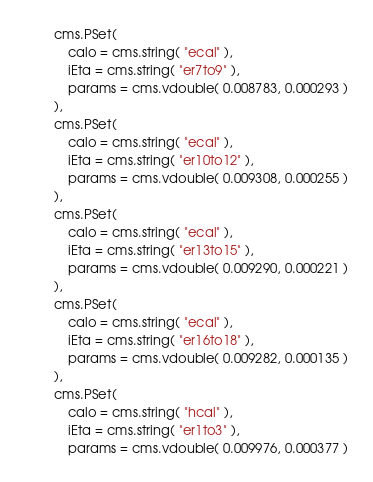Convert code to text. <code><loc_0><loc_0><loc_500><loc_500><_Python_>		cms.PSet(
			calo = cms.string( "ecal" ),
			iEta = cms.string( "er7to9" ),
			params = cms.vdouble( 0.008783, 0.000293 )
		),
		cms.PSet(
			calo = cms.string( "ecal" ),
			iEta = cms.string( "er10to12" ),
			params = cms.vdouble( 0.009308, 0.000255 )
		),
		cms.PSet(
			calo = cms.string( "ecal" ),
			iEta = cms.string( "er13to15" ),
			params = cms.vdouble( 0.009290, 0.000221 )
		),
		cms.PSet(
			calo = cms.string( "ecal" ),
			iEta = cms.string( "er16to18" ),
			params = cms.vdouble( 0.009282, 0.000135 )
		),
		cms.PSet(
			calo = cms.string( "hcal" ),
			iEta = cms.string( "er1to3" ),
			params = cms.vdouble( 0.009976, 0.000377 )</code> 